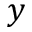Convert formula to latex. <formula><loc_0><loc_0><loc_500><loc_500>y</formula> 